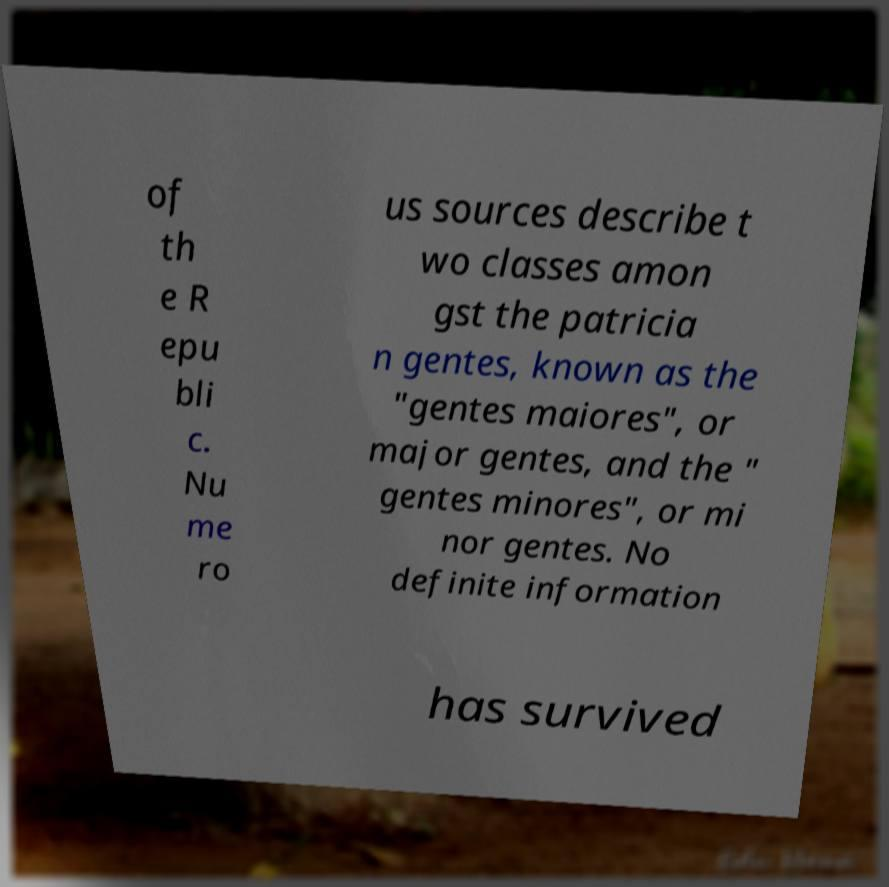Could you assist in decoding the text presented in this image and type it out clearly? of th e R epu bli c. Nu me ro us sources describe t wo classes amon gst the patricia n gentes, known as the "gentes maiores", or major gentes, and the " gentes minores", or mi nor gentes. No definite information has survived 